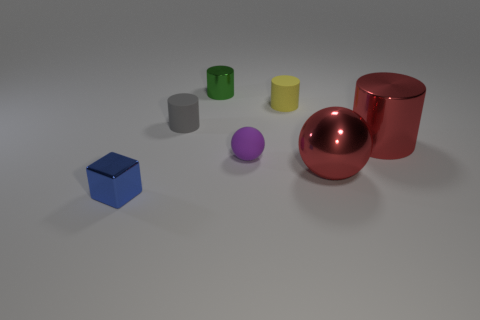How many small things are either green shiny cubes or gray rubber objects?
Your response must be concise. 1. There is a red ball; what number of shiny balls are on the left side of it?
Keep it short and to the point. 0. What is the color of the other tiny rubber thing that is the same shape as the small yellow thing?
Keep it short and to the point. Gray. What number of matte things are either tiny blue blocks or small purple objects?
Offer a terse response. 1. There is a metal cylinder on the right side of the big red thing that is in front of the large metal cylinder; are there any big red shiny things that are in front of it?
Your response must be concise. Yes. What is the color of the small metal cube?
Offer a very short reply. Blue. Is the shape of the rubber object that is in front of the small gray thing the same as  the gray matte thing?
Keep it short and to the point. No. How many objects are either green metallic things or cylinders in front of the tiny green thing?
Offer a very short reply. 4. Does the small cylinder that is to the left of the tiny green cylinder have the same material as the yellow object?
Your answer should be compact. Yes. Are there any other things that are the same size as the purple rubber thing?
Give a very brief answer. Yes. 